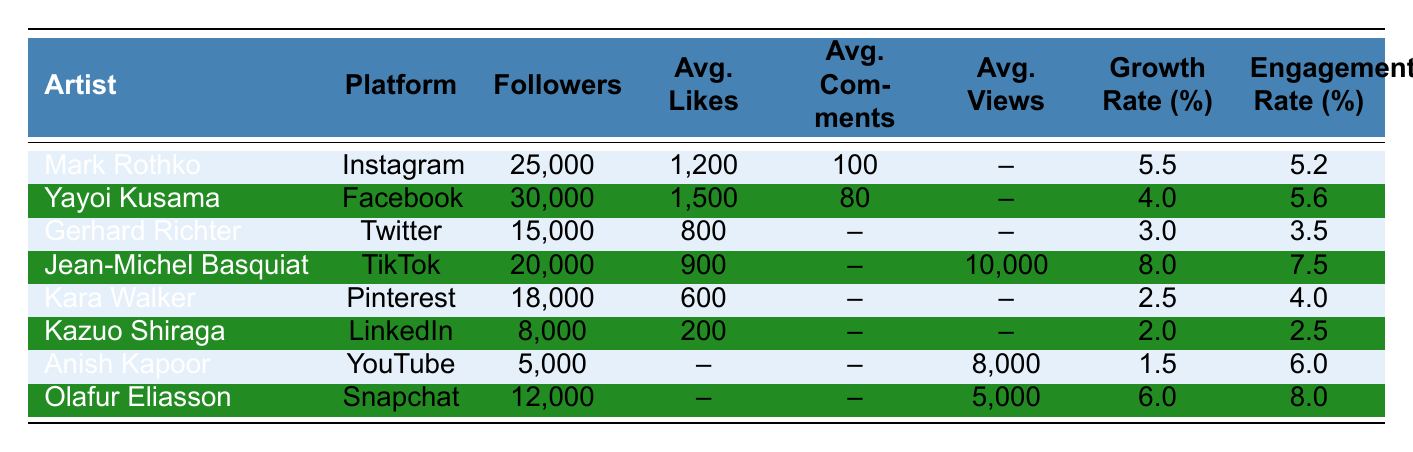What is the highest engagement rate among the artists listed? By looking at the engagement rates in the table, we see that Jean-Michel Basquiat has an engagement rate of 7.5%, which is the highest compared to the others.
Answer: 7.5% Which platform does Yayoi Kusama use and how many followers does she have? From the table, Yayoi Kusama uses Facebook and has 30,000 followers.
Answer: Facebook, 30,000 What is the average number of likes for artists on Instagram and TikTok? Mark Rothko's average likes on Instagram are 1,200 and Jean-Michel Basquiat's average likes on TikTok are 900. The average is calculated as (1200 + 900) / 2 = 1050.
Answer: 1050 True or False: Anish Kapoor has more followers than Kara Walker. Anish Kapoor has 5,000 followers, and Kara Walker has 18,000 followers, so the statement is false.
Answer: False Which artist has the lowest growth rate and what is it? The lowest growth rate in the table is for Anish Kapoor, at 1.5%.
Answer: 1.5% What is the average number of followers for artists on LinkedIn and YouTube? Kazuo Shiraga has 8,000 followers on LinkedIn, and Anish Kapoor has 5,000 followers on YouTube. The average is (8000 + 5000) / 2 = 6500.
Answer: 6500 Which artist has the highest number of followers and on which platform? Yayoi Kusama has the highest number of followers at 30,000 on Facebook.
Answer: Yayoi Kusama, Facebook If we combine the average likes of all artists on Twitter and Snapchat, what would it be? Gerhard Richter has 800 average likes on Twitter while Olafur Eliasson does not have a specified average likes on Snapchat. Given this, we only consider Gerhard Richter's average likes which is 800. The combined average is just 800 since Olafur has no likes provided.
Answer: 800 Which artist has the most followers and what is their engagement rate? Yayoi Kusama has the most followers at 30,000 and an engagement rate of 5.6%.
Answer: Yayoi Kusama, 5.6% What is the difference between the average likes of Gerhard Richter and Mark Rothko? Gerhard Richter has 800 average likes and Mark Rothko has 1,200. The difference is calculated as 1200 - 800 = 400.
Answer: 400 